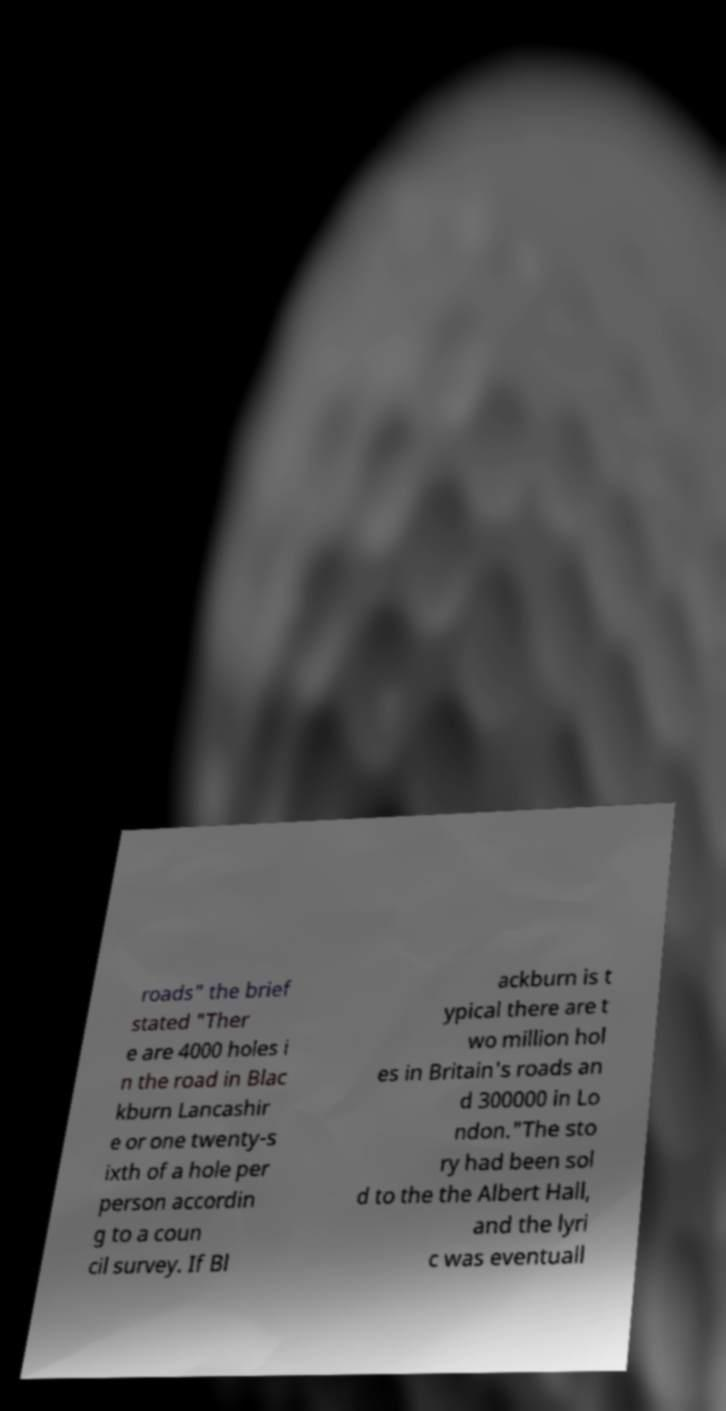Can you accurately transcribe the text from the provided image for me? roads" the brief stated "Ther e are 4000 holes i n the road in Blac kburn Lancashir e or one twenty-s ixth of a hole per person accordin g to a coun cil survey. If Bl ackburn is t ypical there are t wo million hol es in Britain's roads an d 300000 in Lo ndon."The sto ry had been sol d to the the Albert Hall, and the lyri c was eventuall 